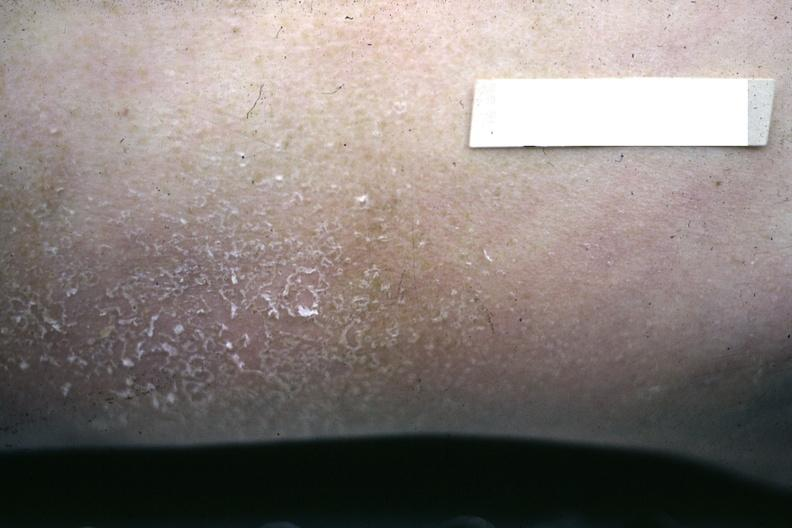where is this?
Answer the question using a single word or phrase. Skin 